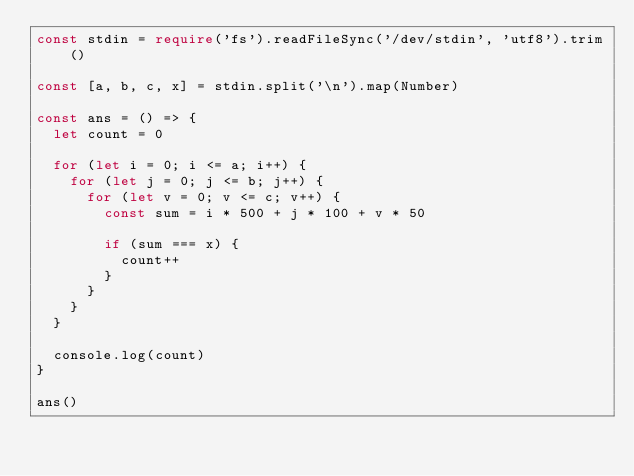Convert code to text. <code><loc_0><loc_0><loc_500><loc_500><_TypeScript_>const stdin = require('fs').readFileSync('/dev/stdin', 'utf8').trim()

const [a, b, c, x] = stdin.split('\n').map(Number)

const ans = () => {
  let count = 0

  for (let i = 0; i <= a; i++) {
    for (let j = 0; j <= b; j++) {
      for (let v = 0; v <= c; v++) {
        const sum = i * 500 + j * 100 + v * 50

        if (sum === x) {
          count++
        }
      }
    }
  }

  console.log(count)
}

ans()
</code> 